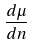<formula> <loc_0><loc_0><loc_500><loc_500>\frac { d \mu } { d n }</formula> 